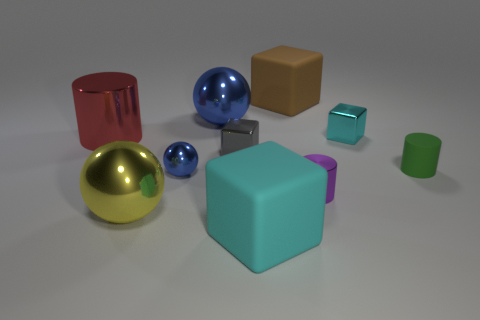Are there more tiny cubes to the right of the large blue thing than large cylinders?
Provide a succinct answer. Yes. Is the cyan thing to the right of the big cyan cube made of the same material as the tiny sphere?
Offer a terse response. Yes. What is the size of the cyan shiny thing to the right of the shiny cylinder to the left of the blue metallic thing that is in front of the tiny green rubber object?
Give a very brief answer. Small. There is a yellow ball that is the same material as the tiny cyan object; what is its size?
Make the answer very short. Large. The thing that is both on the right side of the large blue metallic object and behind the small cyan thing is what color?
Offer a very short reply. Brown. Does the rubber thing to the right of the purple object have the same shape as the cyan thing that is behind the large yellow shiny object?
Your response must be concise. No. There is a large cube that is in front of the big blue metal sphere; what material is it?
Ensure brevity in your answer.  Rubber. How many things are either shiny objects left of the big blue shiny object or small rubber objects?
Your answer should be very brief. 4. Is the number of big yellow metal things to the left of the yellow object the same as the number of cyan rubber things?
Offer a very short reply. No. Do the brown matte cube and the gray metallic block have the same size?
Provide a succinct answer. No. 